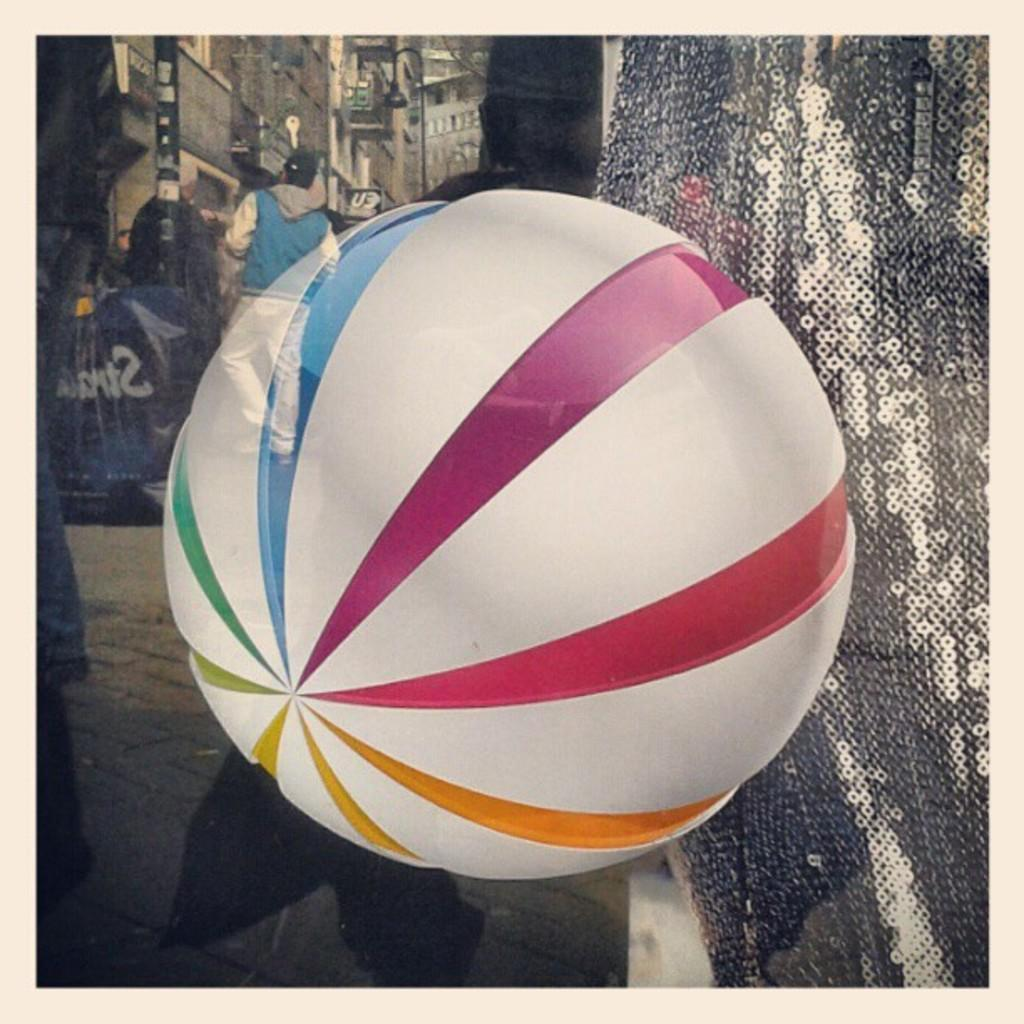What can be seen floating in the image? There is a colorful balloon in the image. What type of material is present in the image that appears to be shiny? There is a shining cloth in the image. Who or what is visible in the image? There are people visible in the image. What type of structures can be seen in the image? There are buildings in the image. What is hanging or displayed in the image? There is a banner in the image. What type of pathway is present in the image? There is a road in the image. What type of attraction can be seen quivering in the image? There is no attraction present in the image, nor is anything quivering. 